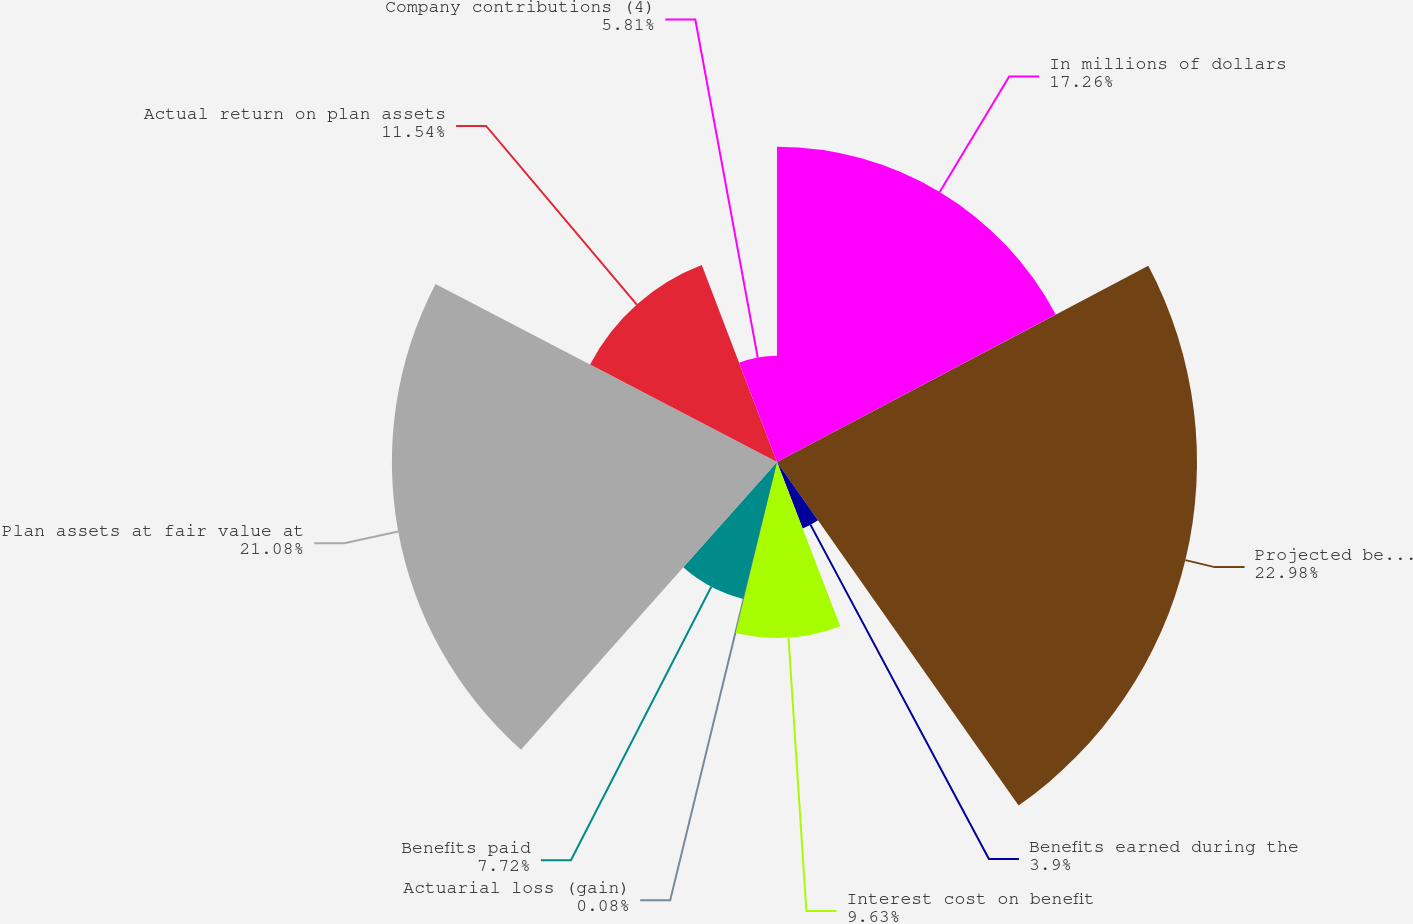Convert chart to OTSL. <chart><loc_0><loc_0><loc_500><loc_500><pie_chart><fcel>In millions of dollars<fcel>Projected benefit obligation<fcel>Benefits earned during the<fcel>Interest cost on benefit<fcel>Actuarial loss (gain)<fcel>Benefits paid<fcel>Plan assets at fair value at<fcel>Actual return on plan assets<fcel>Company contributions (4)<nl><fcel>17.26%<fcel>22.99%<fcel>3.9%<fcel>9.63%<fcel>0.08%<fcel>7.72%<fcel>21.08%<fcel>11.54%<fcel>5.81%<nl></chart> 